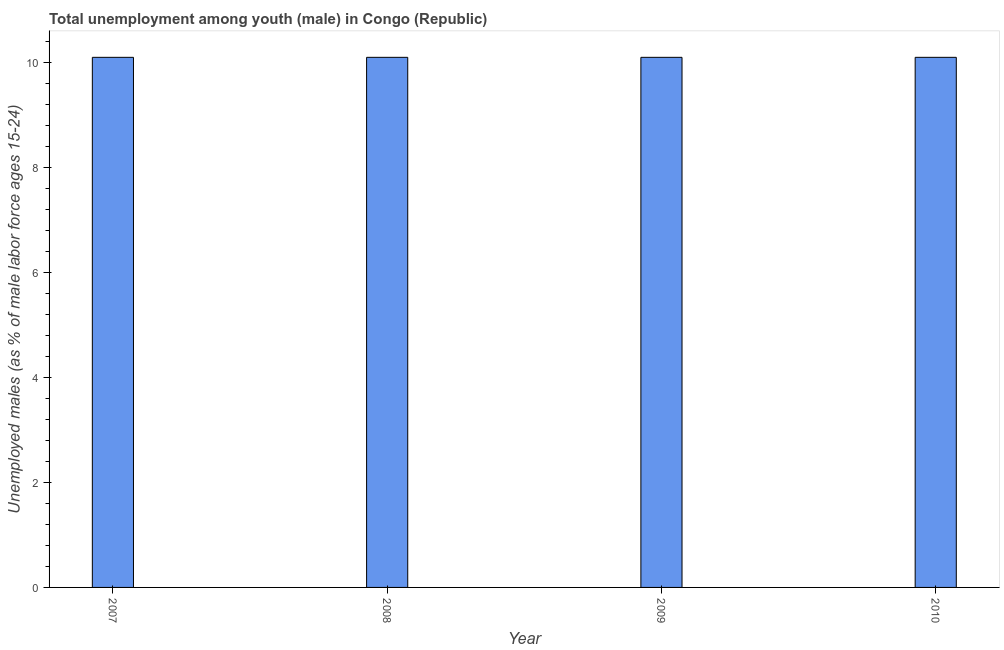Does the graph contain grids?
Ensure brevity in your answer.  No. What is the title of the graph?
Your answer should be compact. Total unemployment among youth (male) in Congo (Republic). What is the label or title of the X-axis?
Ensure brevity in your answer.  Year. What is the label or title of the Y-axis?
Provide a succinct answer. Unemployed males (as % of male labor force ages 15-24). What is the unemployed male youth population in 2008?
Ensure brevity in your answer.  10.1. Across all years, what is the maximum unemployed male youth population?
Give a very brief answer. 10.1. Across all years, what is the minimum unemployed male youth population?
Your answer should be compact. 10.1. In which year was the unemployed male youth population maximum?
Offer a very short reply. 2007. In which year was the unemployed male youth population minimum?
Provide a short and direct response. 2007. What is the sum of the unemployed male youth population?
Give a very brief answer. 40.4. What is the difference between the unemployed male youth population in 2007 and 2009?
Ensure brevity in your answer.  0. What is the median unemployed male youth population?
Your response must be concise. 10.1. Is the unemployed male youth population in 2008 less than that in 2009?
Make the answer very short. No. Is the difference between the unemployed male youth population in 2007 and 2009 greater than the difference between any two years?
Provide a succinct answer. Yes. What is the difference between the highest and the second highest unemployed male youth population?
Your answer should be very brief. 0. Is the sum of the unemployed male youth population in 2007 and 2008 greater than the maximum unemployed male youth population across all years?
Your response must be concise. Yes. How many years are there in the graph?
Keep it short and to the point. 4. What is the difference between two consecutive major ticks on the Y-axis?
Keep it short and to the point. 2. What is the Unemployed males (as % of male labor force ages 15-24) of 2007?
Provide a short and direct response. 10.1. What is the Unemployed males (as % of male labor force ages 15-24) in 2008?
Provide a succinct answer. 10.1. What is the Unemployed males (as % of male labor force ages 15-24) in 2009?
Offer a very short reply. 10.1. What is the Unemployed males (as % of male labor force ages 15-24) in 2010?
Make the answer very short. 10.1. What is the difference between the Unemployed males (as % of male labor force ages 15-24) in 2007 and 2008?
Your answer should be compact. 0. What is the difference between the Unemployed males (as % of male labor force ages 15-24) in 2007 and 2009?
Offer a terse response. 0. What is the difference between the Unemployed males (as % of male labor force ages 15-24) in 2008 and 2010?
Your answer should be compact. 0. What is the difference between the Unemployed males (as % of male labor force ages 15-24) in 2009 and 2010?
Keep it short and to the point. 0. What is the ratio of the Unemployed males (as % of male labor force ages 15-24) in 2007 to that in 2008?
Offer a terse response. 1. What is the ratio of the Unemployed males (as % of male labor force ages 15-24) in 2007 to that in 2009?
Make the answer very short. 1. What is the ratio of the Unemployed males (as % of male labor force ages 15-24) in 2007 to that in 2010?
Make the answer very short. 1. What is the ratio of the Unemployed males (as % of male labor force ages 15-24) in 2009 to that in 2010?
Provide a short and direct response. 1. 